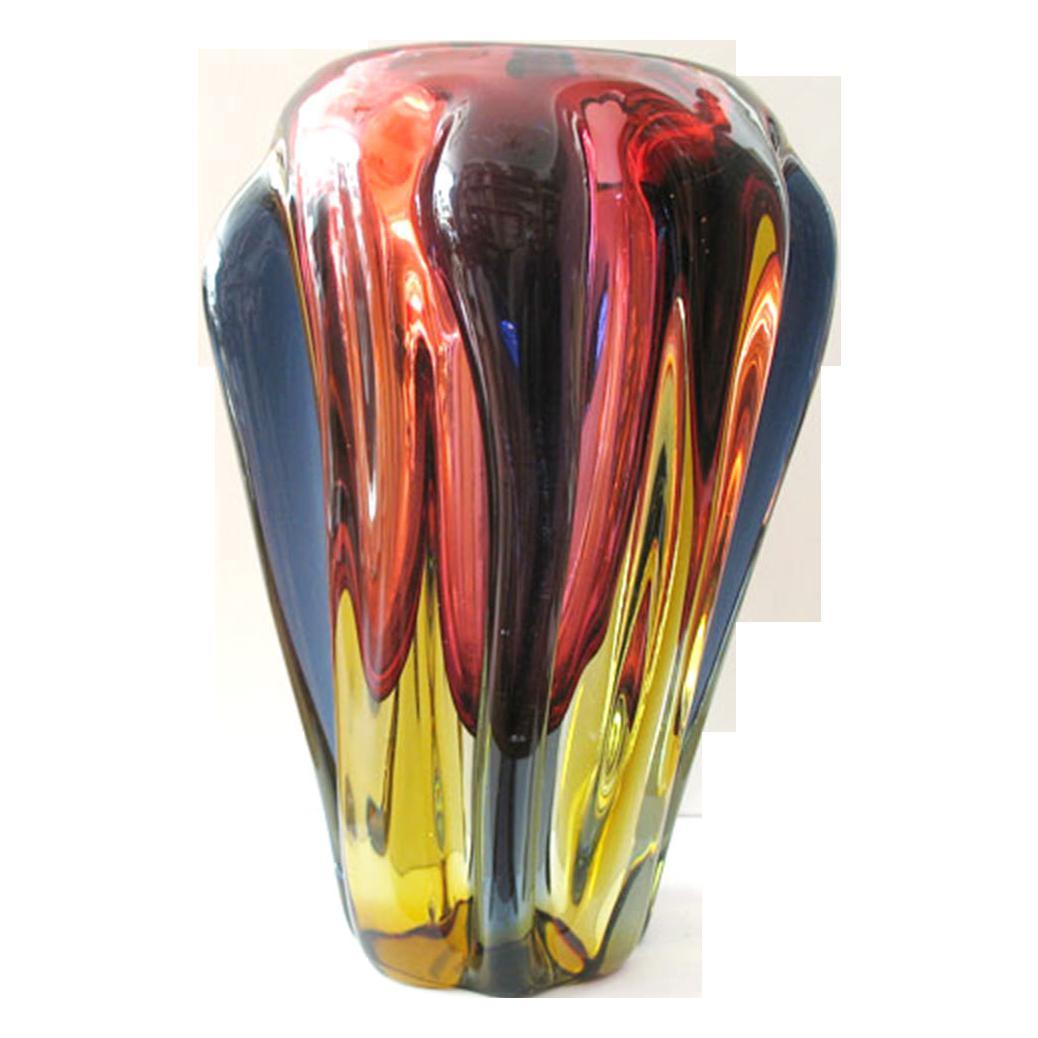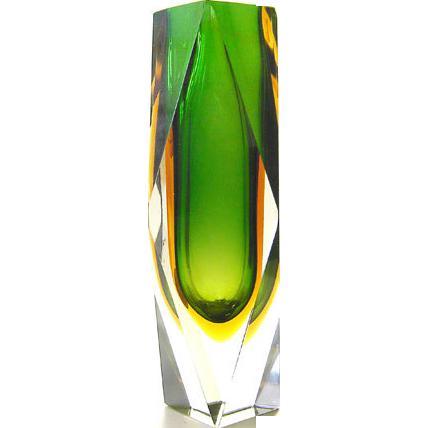The first image is the image on the left, the second image is the image on the right. For the images shown, is this caption "Both vases are at least party green." true? Answer yes or no. No. The first image is the image on the left, the second image is the image on the right. Analyze the images presented: Is the assertion "Each image shows a vase that flares at the top and has colored glass without a regular pattern." valid? Answer yes or no. No. 